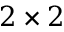<formula> <loc_0><loc_0><loc_500><loc_500>2 \times 2</formula> 